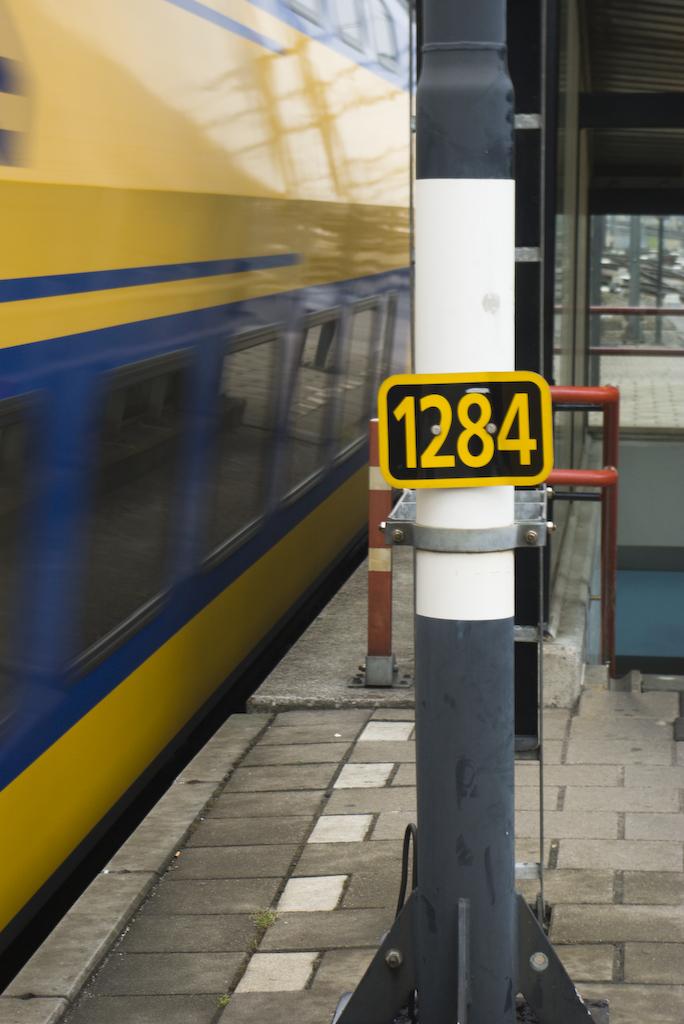What is the 4 digit number?
Provide a short and direct response. 1284. 